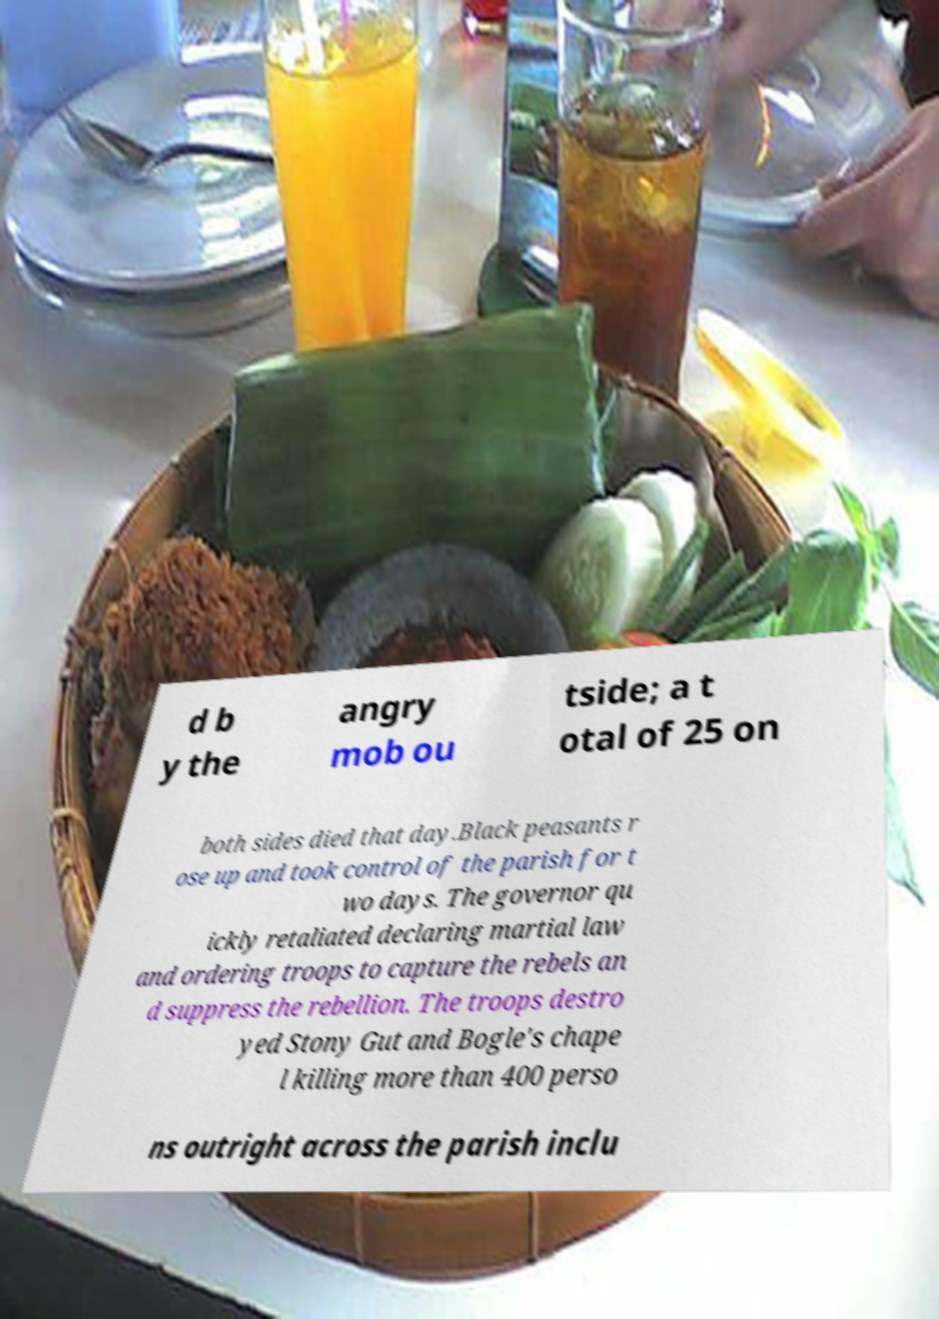There's text embedded in this image that I need extracted. Can you transcribe it verbatim? d b y the angry mob ou tside; a t otal of 25 on both sides died that day.Black peasants r ose up and took control of the parish for t wo days. The governor qu ickly retaliated declaring martial law and ordering troops to capture the rebels an d suppress the rebellion. The troops destro yed Stony Gut and Bogle's chape l killing more than 400 perso ns outright across the parish inclu 